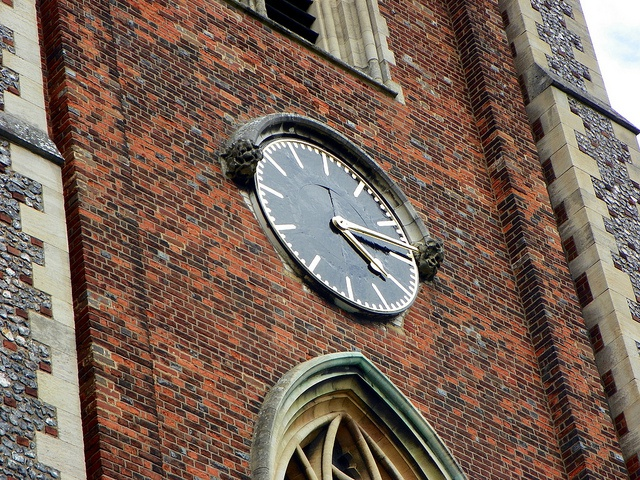Describe the objects in this image and their specific colors. I can see a clock in gray, darkgray, white, and black tones in this image. 